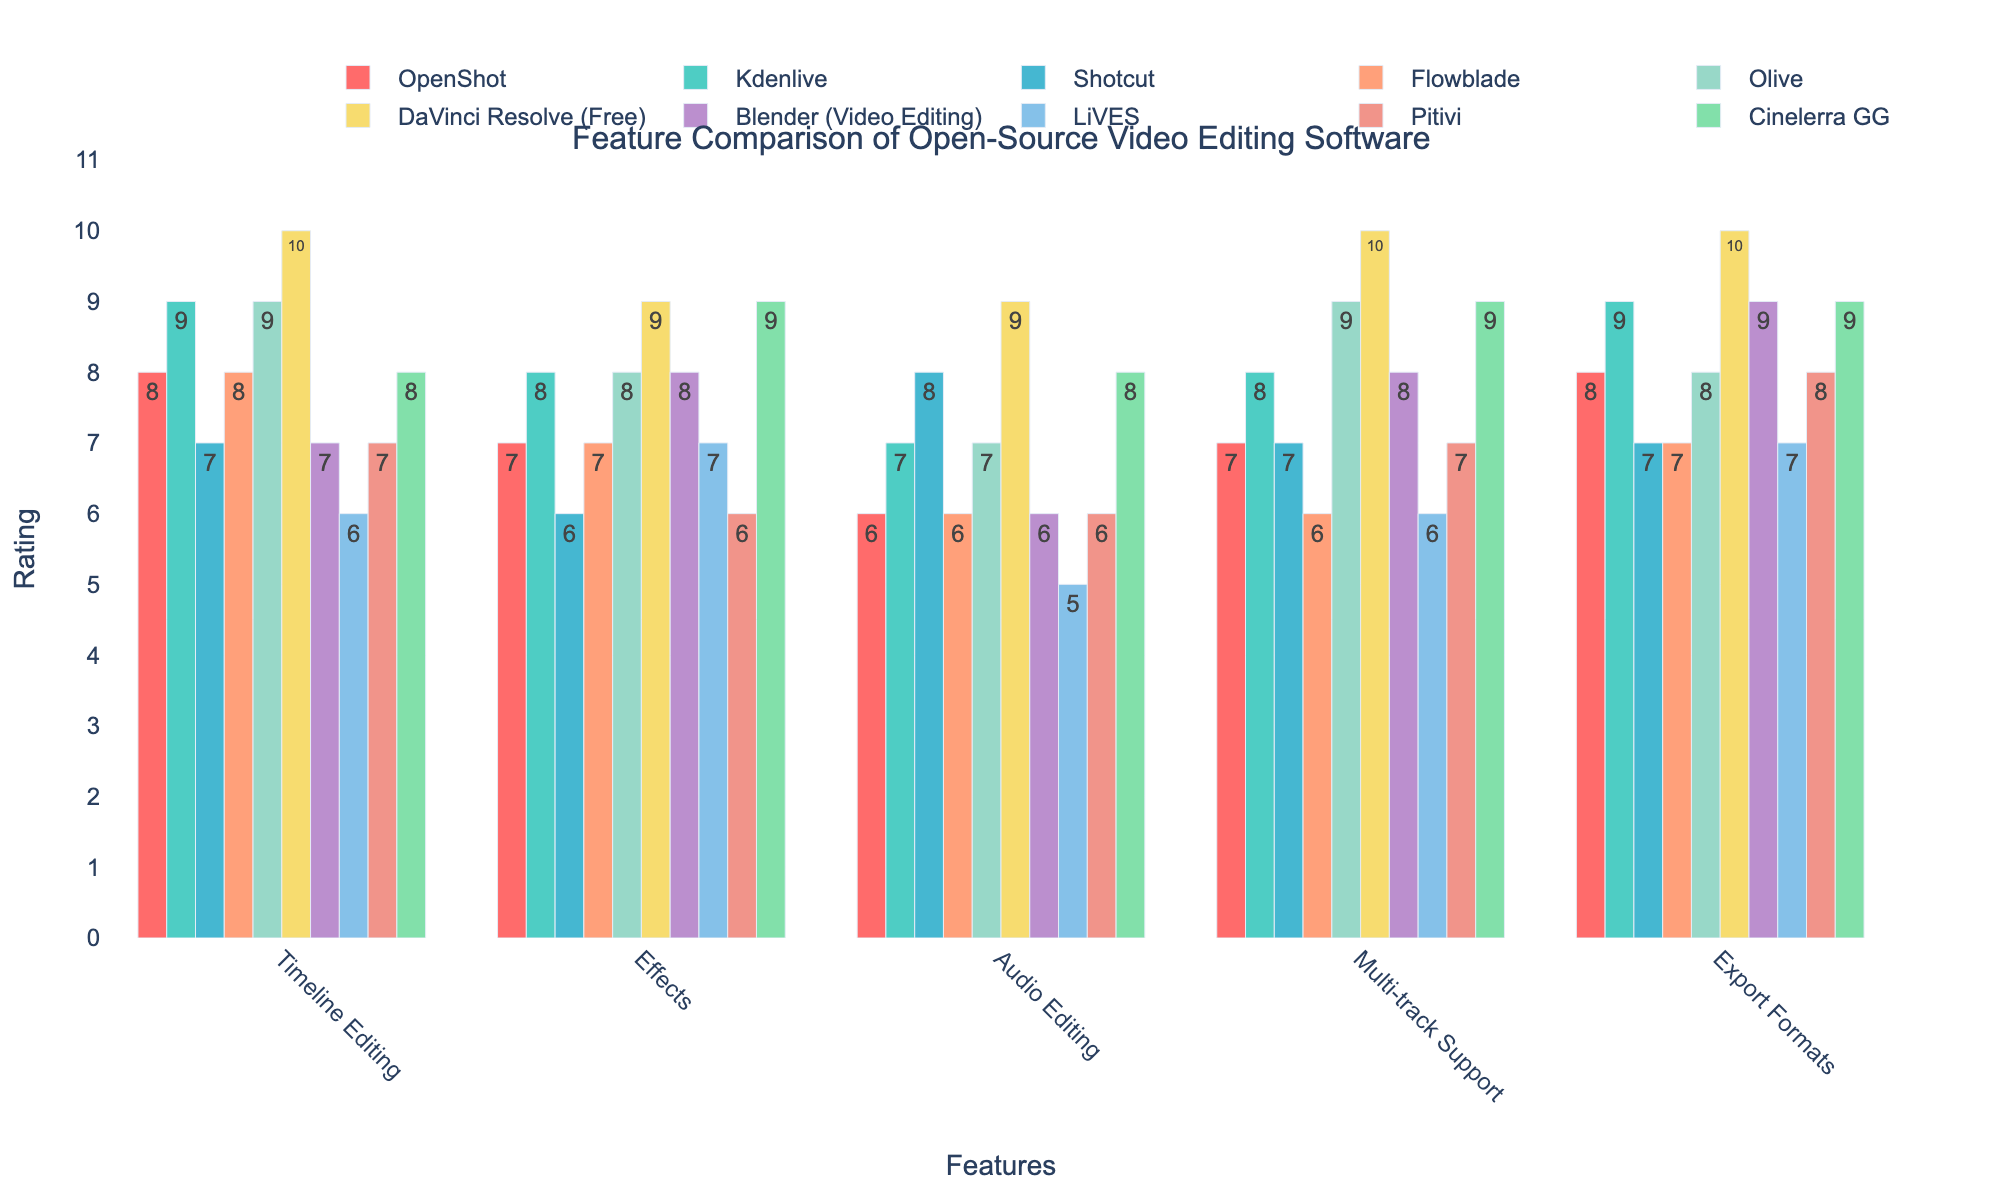What software has the highest rating for Export Formats? The tallest bar in the Export Formats category represents DaVinci Resolve (Free) with a rating of 10
Answer: DaVinci Resolve (Free) Which software has the lowest rating for Audio Editing? The shortest bar in the Audio Editing category represents LiVES with a rating of 5
Answer: LiVES Which software offers better Timeline Editing, Kdenlive or Blender? The bar for Timeline Editing shows that Kdenlive has a rating of 9, while Blender has a rating of 7. Kdenlive's bar is taller, indicating better Timeline Editing
Answer: Kdenlive What is the average rating of OpenShot across all features? The ratings for OpenShot are: 8, 7, 6, 7, and 8. Sum: 8+7+6+7+8 = 36. Average: 36/5 = 7.2
Answer: 7.2 How many software have a rating of 9 or higher for Effects? By visually inspecting the bars for Effects, Kdenlive, DaVinci Resolve (Free), Olive, and Cinelerra GG have a rating of 9 or higher, totaling 4
Answer: 4 Is there any software that has equal ratings for both Timeline Editing and Multi-track Support? Comparing the height of the bars for both Timeline Editing and Multi-track Support, we see that Olive has equal ratings of 9 for both features
Answer: Olive What is the total rating of Shotcut across all features? The ratings for Shotcut are: 7, 6, 8, 7, and 7. Sum: 7+6+8+7+7 = 35
Answer: 35 Which software has a higher rating for Effects, Shotcut or Pitivi, and by how much? Shotcut has a rating of 6 for Effects, while Pitivi has a rating of 6. The difference is 6 - 6 = 0
Answer: 0 What is the difference in rating for Audio Editing between DaVinci Resolve (Free) and Flowblade? DaVinci Resolve (Free) has a rating of 9 for Audio Editing, and Flowblade has a rating of 6. The difference is 9 - 6 = 3
Answer: 3 